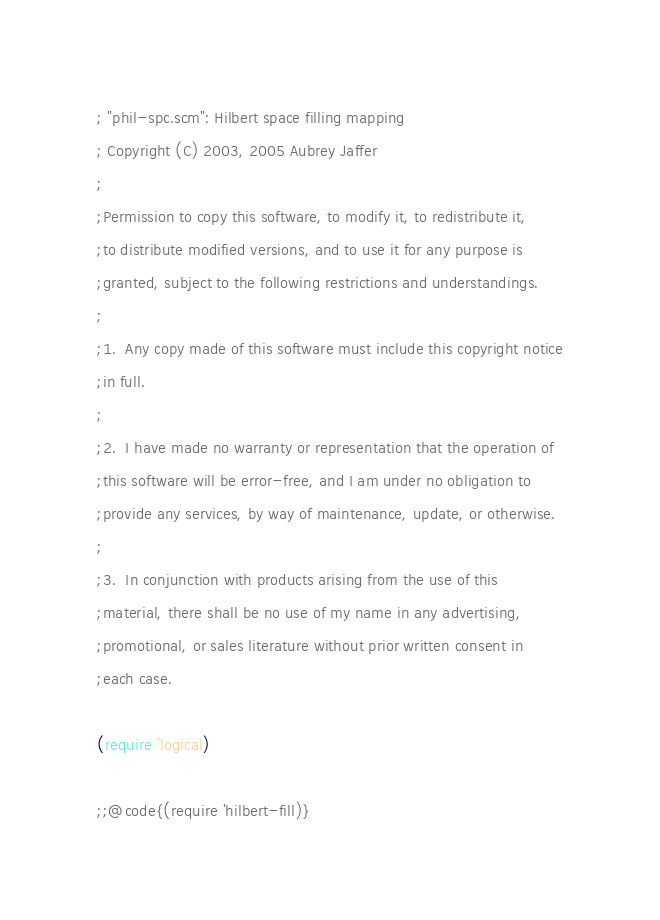<code> <loc_0><loc_0><loc_500><loc_500><_Scheme_>; "phil-spc.scm": Hilbert space filling mapping
; Copyright (C) 2003, 2005 Aubrey Jaffer
;
;Permission to copy this software, to modify it, to redistribute it,
;to distribute modified versions, and to use it for any purpose is
;granted, subject to the following restrictions and understandings.
;
;1.  Any copy made of this software must include this copyright notice
;in full.
;
;2.  I have made no warranty or representation that the operation of
;this software will be error-free, and I am under no obligation to
;provide any services, by way of maintenance, update, or otherwise.
;
;3.  In conjunction with products arising from the use of this
;material, there shall be no use of my name in any advertising,
;promotional, or sales literature without prior written consent in
;each case.

(require 'logical)

;;@code{(require 'hilbert-fill)}</code> 